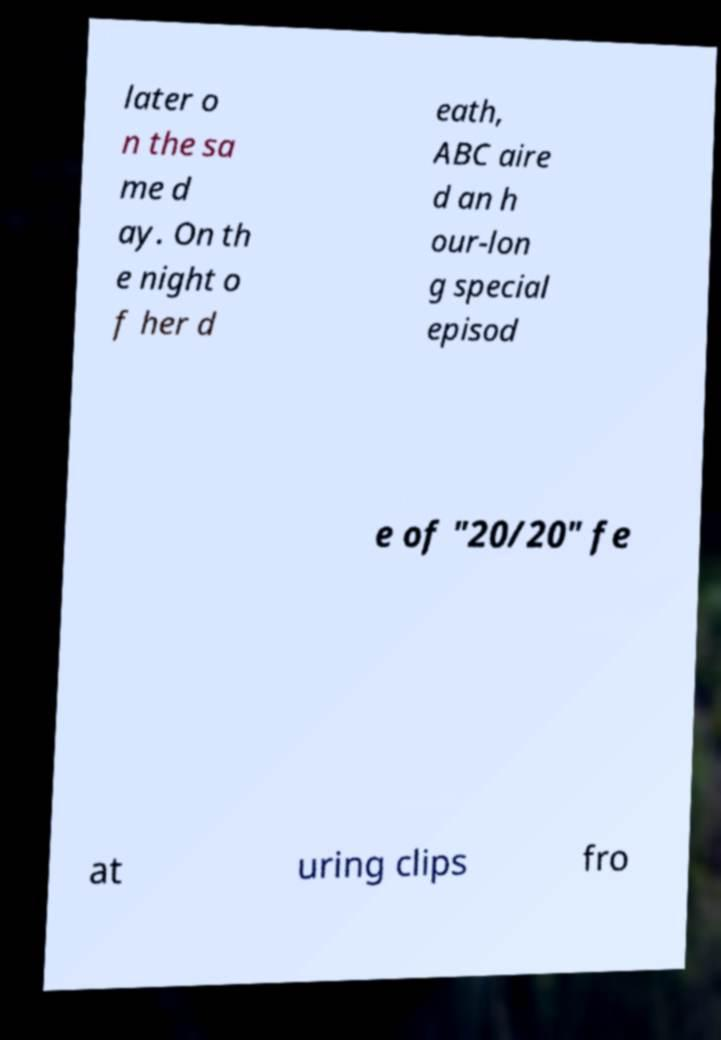Please identify and transcribe the text found in this image. later o n the sa me d ay. On th e night o f her d eath, ABC aire d an h our-lon g special episod e of "20/20" fe at uring clips fro 